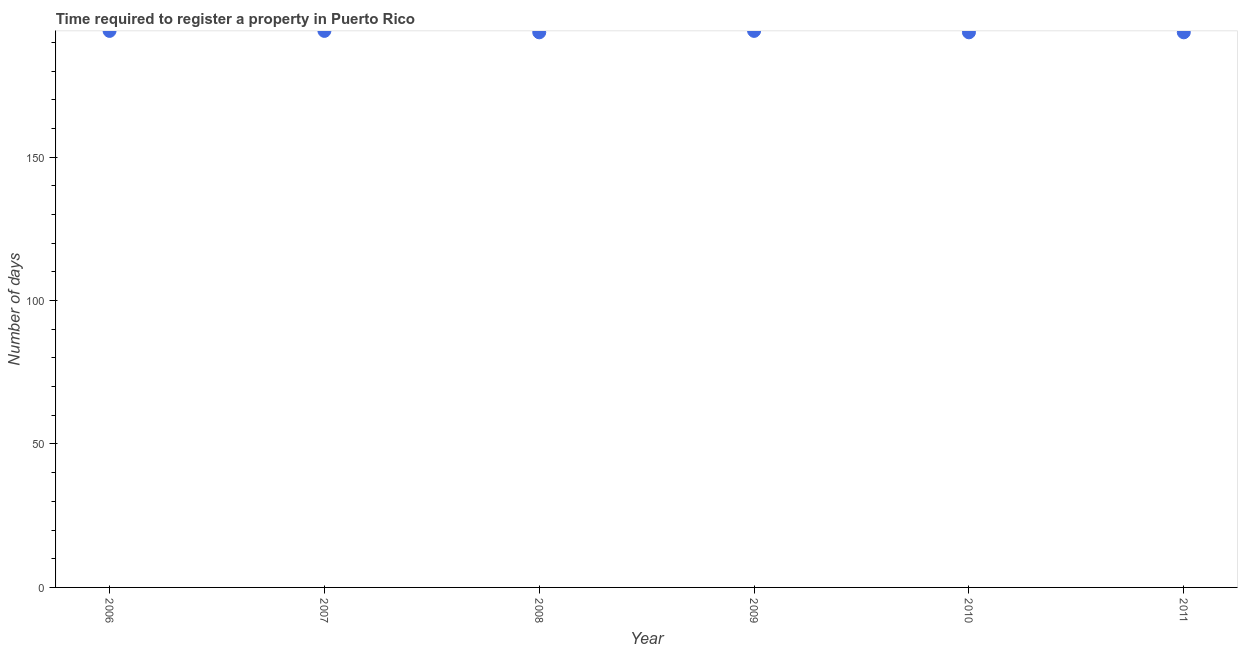What is the number of days required to register property in 2008?
Provide a succinct answer. 193.5. Across all years, what is the maximum number of days required to register property?
Your answer should be compact. 194. Across all years, what is the minimum number of days required to register property?
Keep it short and to the point. 193.5. In which year was the number of days required to register property minimum?
Ensure brevity in your answer.  2008. What is the sum of the number of days required to register property?
Your answer should be very brief. 1162.5. What is the difference between the number of days required to register property in 2007 and 2008?
Offer a very short reply. 0.5. What is the average number of days required to register property per year?
Keep it short and to the point. 193.75. What is the median number of days required to register property?
Your answer should be compact. 193.75. In how many years, is the number of days required to register property greater than 100 days?
Your answer should be very brief. 6. Do a majority of the years between 2011 and 2010 (inclusive) have number of days required to register property greater than 120 days?
Give a very brief answer. No. What is the ratio of the number of days required to register property in 2006 to that in 2007?
Provide a succinct answer. 1. What is the difference between the highest and the second highest number of days required to register property?
Your answer should be compact. 0. Is the sum of the number of days required to register property in 2008 and 2010 greater than the maximum number of days required to register property across all years?
Your answer should be compact. Yes. In how many years, is the number of days required to register property greater than the average number of days required to register property taken over all years?
Your answer should be compact. 3. Does the number of days required to register property monotonically increase over the years?
Your response must be concise. No. How many dotlines are there?
Make the answer very short. 1. How many years are there in the graph?
Your answer should be compact. 6. What is the difference between two consecutive major ticks on the Y-axis?
Your answer should be compact. 50. Does the graph contain any zero values?
Keep it short and to the point. No. What is the title of the graph?
Your answer should be very brief. Time required to register a property in Puerto Rico. What is the label or title of the X-axis?
Give a very brief answer. Year. What is the label or title of the Y-axis?
Give a very brief answer. Number of days. What is the Number of days in 2006?
Provide a short and direct response. 194. What is the Number of days in 2007?
Keep it short and to the point. 194. What is the Number of days in 2008?
Offer a very short reply. 193.5. What is the Number of days in 2009?
Give a very brief answer. 194. What is the Number of days in 2010?
Your answer should be compact. 193.5. What is the Number of days in 2011?
Provide a short and direct response. 193.5. What is the difference between the Number of days in 2006 and 2009?
Offer a very short reply. 0. What is the difference between the Number of days in 2007 and 2008?
Provide a short and direct response. 0.5. What is the difference between the Number of days in 2007 and 2009?
Provide a succinct answer. 0. What is the difference between the Number of days in 2007 and 2010?
Give a very brief answer. 0.5. What is the difference between the Number of days in 2008 and 2010?
Keep it short and to the point. 0. What is the difference between the Number of days in 2010 and 2011?
Ensure brevity in your answer.  0. What is the ratio of the Number of days in 2006 to that in 2009?
Give a very brief answer. 1. What is the ratio of the Number of days in 2006 to that in 2011?
Keep it short and to the point. 1. What is the ratio of the Number of days in 2007 to that in 2009?
Your answer should be very brief. 1. What is the ratio of the Number of days in 2008 to that in 2009?
Make the answer very short. 1. What is the ratio of the Number of days in 2008 to that in 2010?
Provide a short and direct response. 1. What is the ratio of the Number of days in 2008 to that in 2011?
Ensure brevity in your answer.  1. 